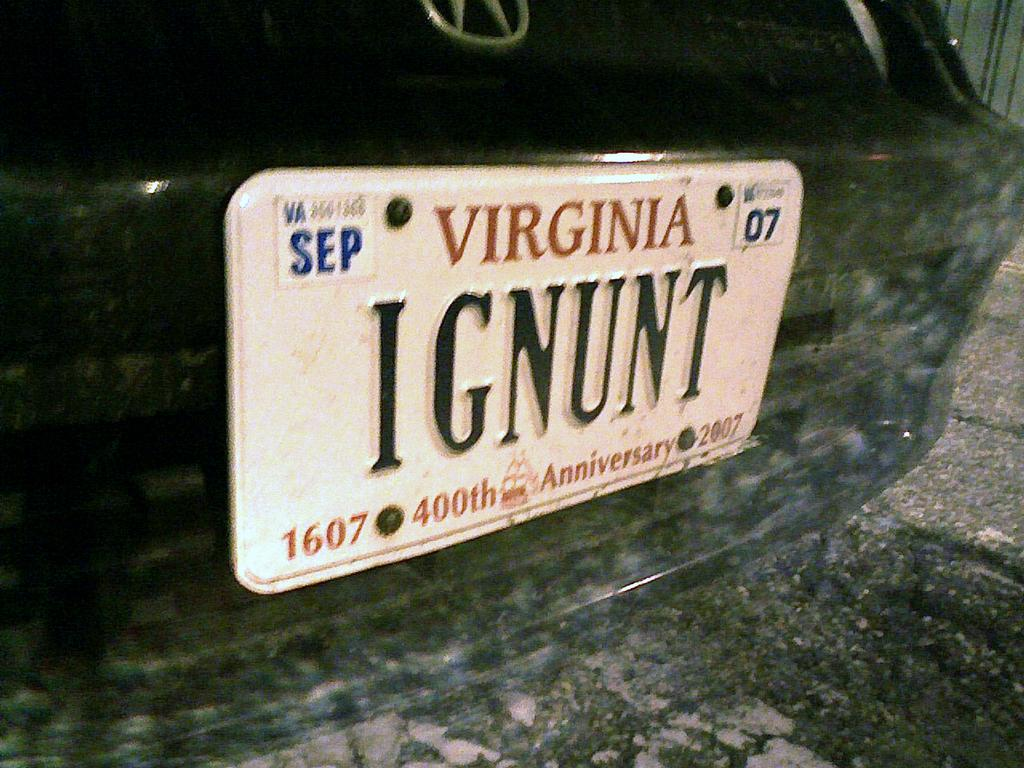<image>
Present a compact description of the photo's key features. A Virginia tag on a black car that reads IGNUNT. 